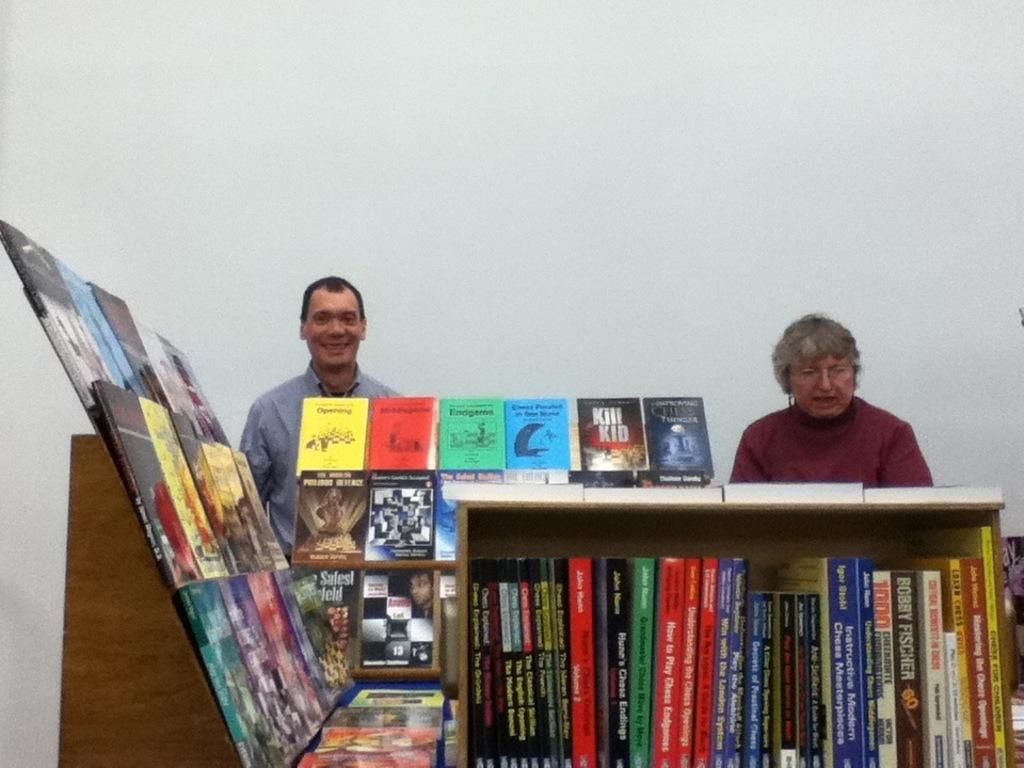On the top row of books, what is the title of the one that is second to the right?
Your response must be concise. Kill kid. 